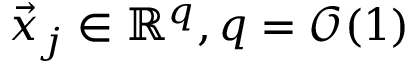<formula> <loc_0><loc_0><loc_500><loc_500>\vec { x } _ { j } \in \mathbb { R } ^ { q } , q = \mathcal { O } ( 1 )</formula> 